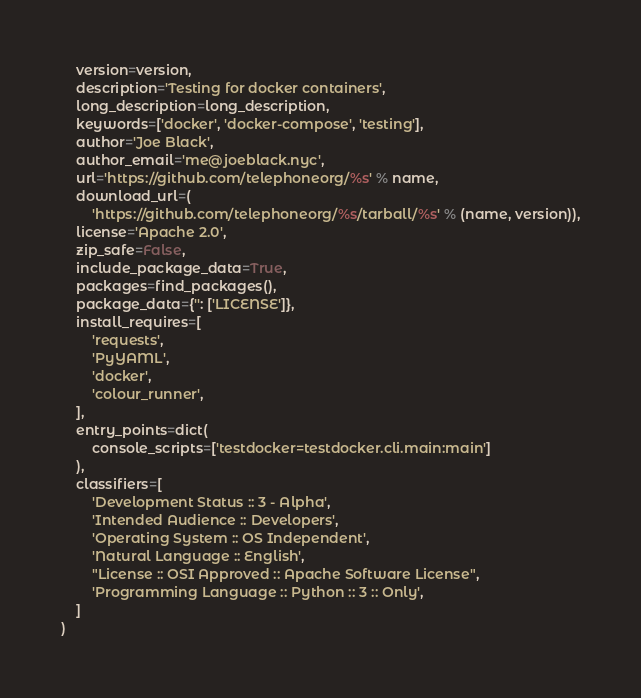<code> <loc_0><loc_0><loc_500><loc_500><_Python_>    version=version,
    description='Testing for docker containers',
    long_description=long_description,
    keywords=['docker', 'docker-compose', 'testing'],
    author='Joe Black',
    author_email='me@joeblack.nyc',
    url='https://github.com/telephoneorg/%s' % name,
    download_url=(
        'https://github.com/telephoneorg/%s/tarball/%s' % (name, version)),
    license='Apache 2.0',
    zip_safe=False,
    include_package_data=True,
    packages=find_packages(),
    package_data={'': ['LICENSE']},
    install_requires=[
        'requests',
        'PyYAML',
        'docker',
        'colour_runner',
    ],
    entry_points=dict(
        console_scripts=['testdocker=testdocker.cli.main:main']
    ),
    classifiers=[
        'Development Status :: 3 - Alpha',
        'Intended Audience :: Developers',
        'Operating System :: OS Independent',
        'Natural Language :: English',
        "License :: OSI Approved :: Apache Software License",
        'Programming Language :: Python :: 3 :: Only',
    ]
)
</code> 